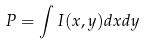Convert formula to latex. <formula><loc_0><loc_0><loc_500><loc_500>P = \int I ( x , y ) d x d y</formula> 